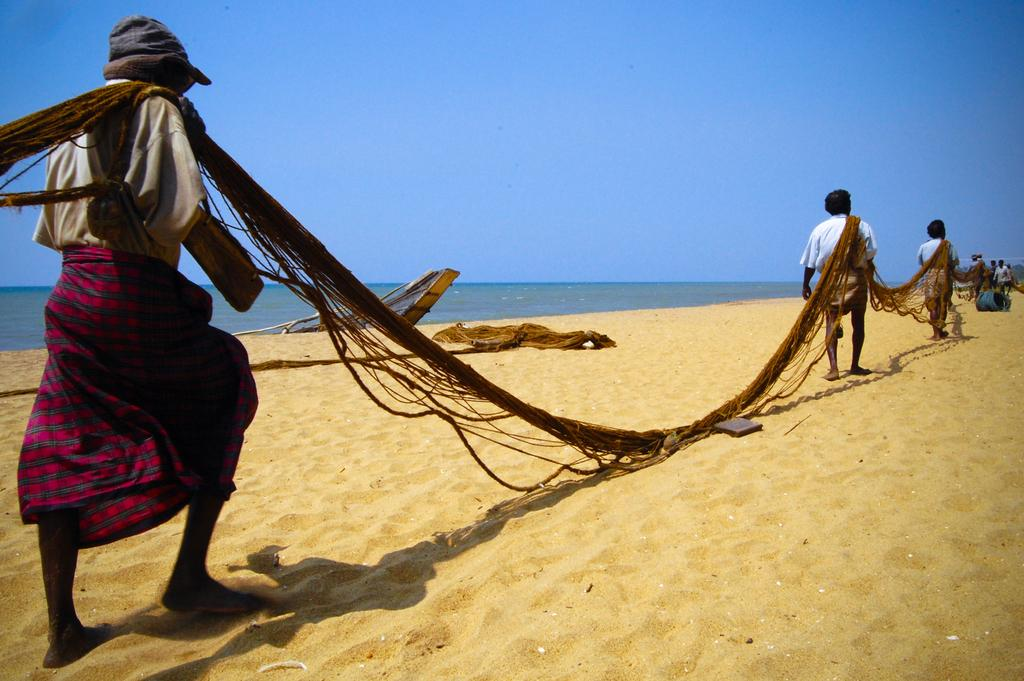How many people are in the image? There is a group of people in the image. What are the people doing in the image? Some people are walking on the sand, and they are holding a net. What can be seen in the background of the image? There is a boat and water visible in the background of the image. What type of skate is being used by the people in the image? There is no skate present in the image; the people are walking on the sand. How does the society depicted in the image function? The image does not depict a society, so it is not possible to determine how it functions. 